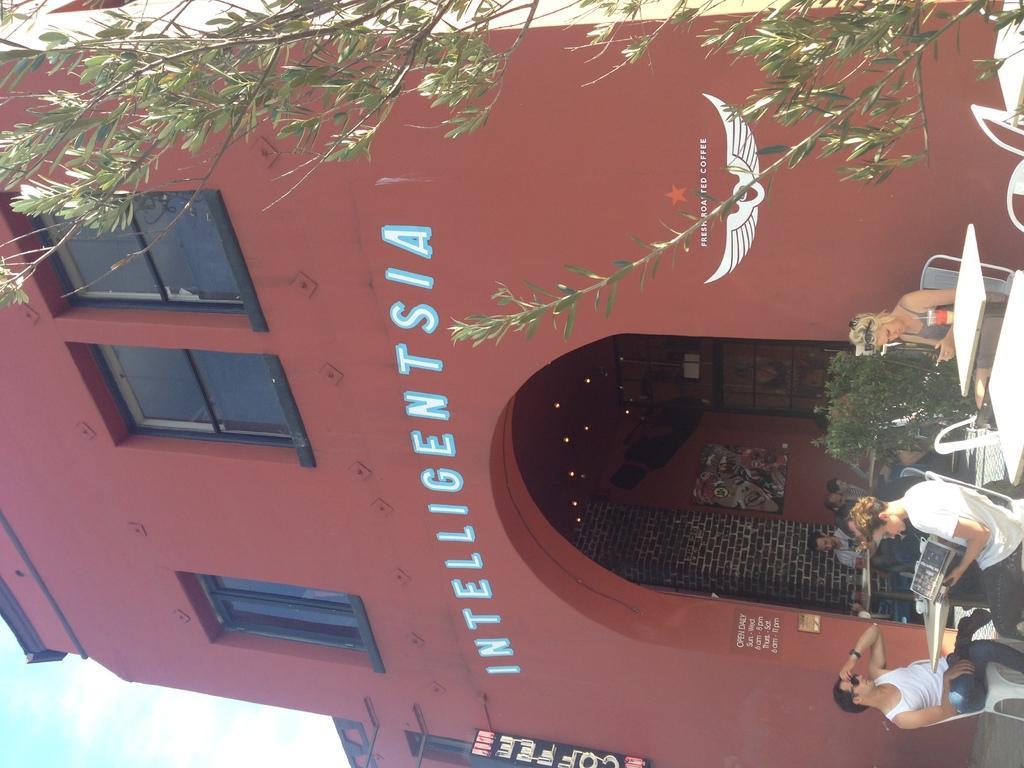In one or two sentences, can you explain what this image depicts? In this image we can see red color building and there are some group of persons sitting on chairs around the tables and there is a tree on right side of the image. 